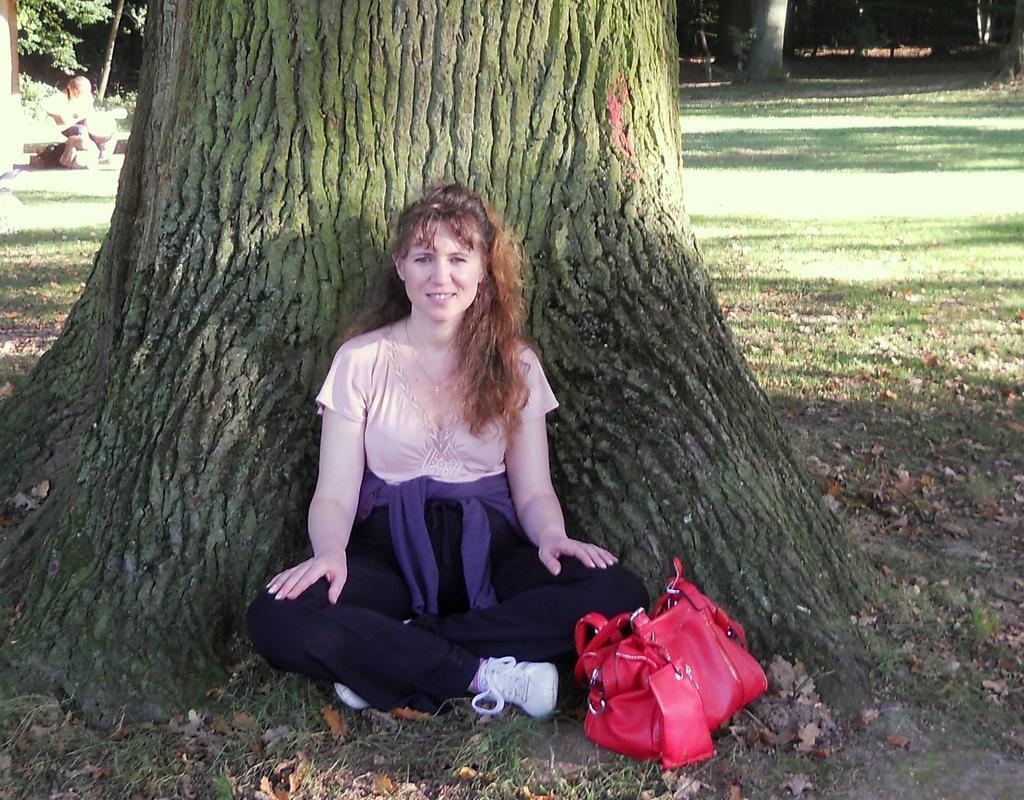Could you give a brief overview of what you see in this image? In the image we can see there is a woman who is sitting under the tree and beside her there is a red colour purse. 